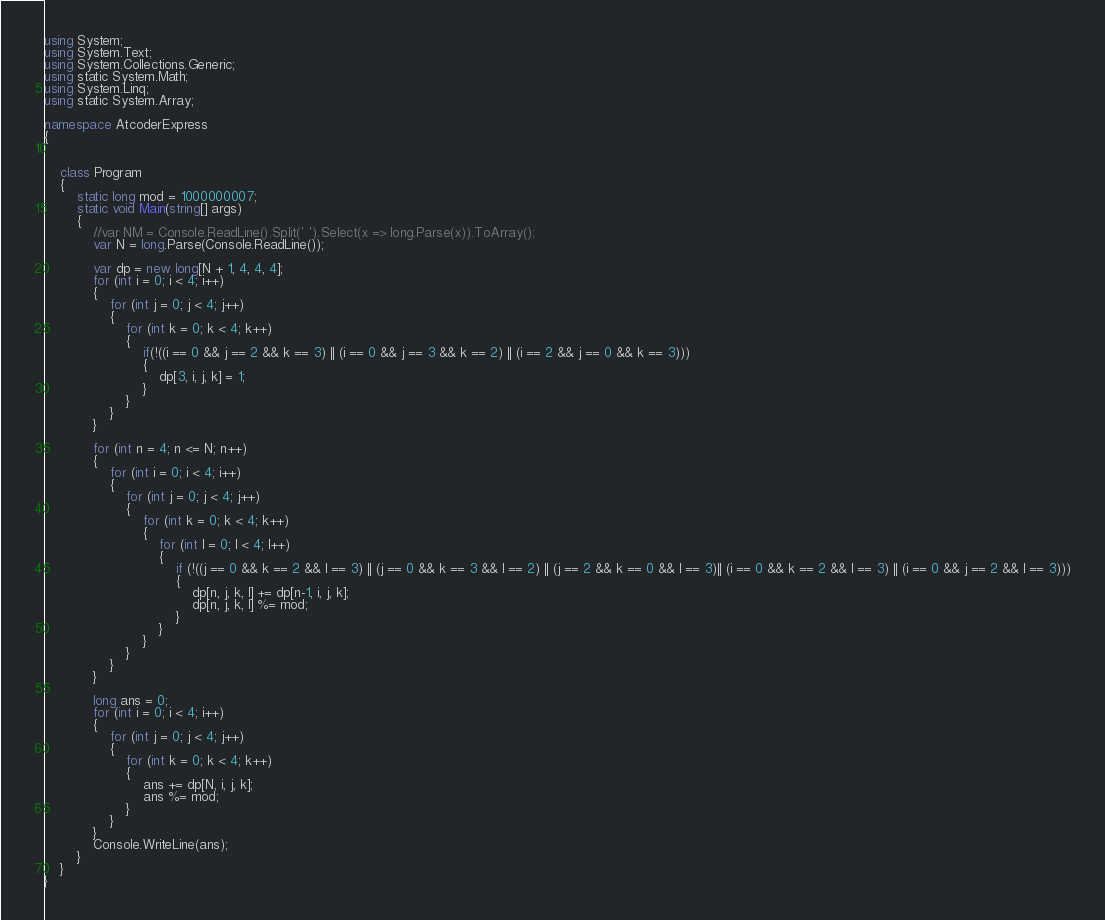Convert code to text. <code><loc_0><loc_0><loc_500><loc_500><_C#_>using System;
using System.Text;
using System.Collections.Generic;
using static System.Math;
using System.Linq;
using static System.Array;

namespace AtcoderExpress
{


    class Program
    {
        static long mod = 1000000007;
        static void Main(string[] args)
        {
            //var NM = Console.ReadLine().Split(' ').Select(x => long.Parse(x)).ToArray();
            var N = long.Parse(Console.ReadLine());

            var dp = new long[N + 1, 4, 4, 4];
            for (int i = 0; i < 4; i++)
            {
                for (int j = 0; j < 4; j++)
                {
                    for (int k = 0; k < 4; k++)
                    {
                        if(!((i == 0 && j == 2 && k == 3) || (i == 0 && j == 3 && k == 2) || (i == 2 && j == 0 && k == 3)))
                        {
                            dp[3, i, j, k] = 1;
                        }
                    }
                }
            }

            for (int n = 4; n <= N; n++)
            {
                for (int i = 0; i < 4; i++)
                {
                    for (int j = 0; j < 4; j++)
                    {
                        for (int k = 0; k < 4; k++)
                        {
                            for (int l = 0; l < 4; l++)
                            {
                                if (!((j == 0 && k == 2 && l == 3) || (j == 0 && k == 3 && l == 2) || (j == 2 && k == 0 && l == 3)|| (i == 0 && k == 2 && l == 3) || (i == 0 && j == 2 && l == 3)))
                                {
                                    dp[n, j, k, l] += dp[n-1, i, j, k];
                                    dp[n, j, k, l] %= mod;
                                }
                            }
                        }
                    }
                }
            }

            long ans = 0;
            for (int i = 0; i < 4; i++)
            {
                for (int j = 0; j < 4; j++)
                {
                    for (int k = 0; k < 4; k++)
                    {
                        ans += dp[N, i, j, k];
                        ans %= mod;
                    }
                }
            }
            Console.WriteLine(ans);
        }
    }
}
</code> 